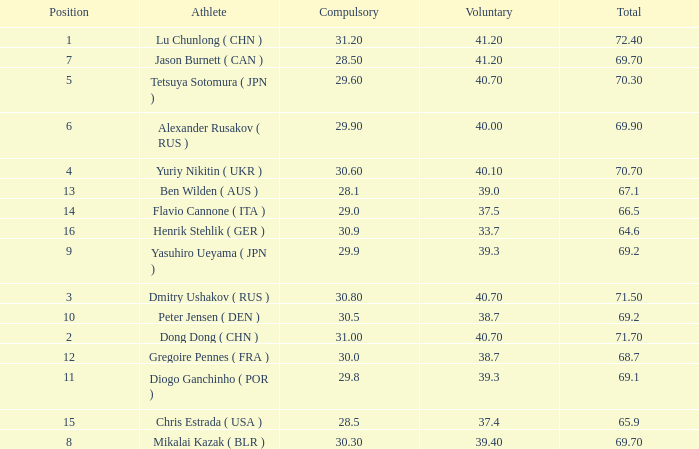What's the total of the position of 1? None. 